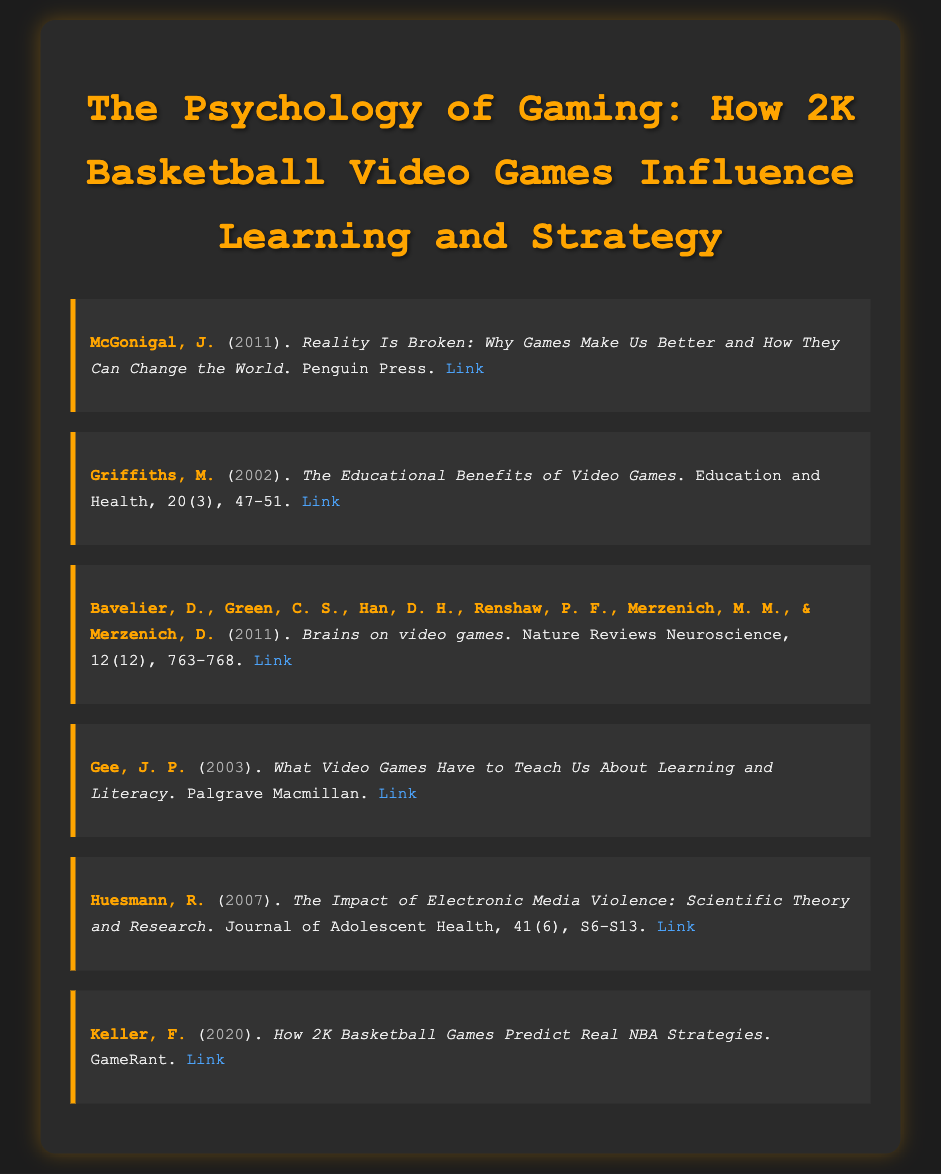What is the title of the document? The title appears at the top of the document and summarizes the main theme.
Answer: The Psychology of Gaming: How 2K Basketball Video Games Influence Learning and Strategy Who is the author of the book "Reality Is Broken"? The author’s name is listed at the beginning of the first item in the bibliography.
Answer: McGonigal, J What year was "The Educational Benefits of Video Games" published? The year is shown in parentheses after the author's name in the second item.
Answer: 2002 Which journal published "The Impact of Electronic Media Violence"? The journal name is found in the citation within the bibliography item.
Answer: Journal of Adolescent Health How many authors contributed to the article "Brains on video games"? The number of authors is counted based on the list in the citation of the third item.
Answer: Six Which game predicts real NBA strategies according to Keller's article? The specific game mentioned in the citation of the sixth item provides this information.
Answer: 2K Basketball Games What is a common theme in the bibliography? The common topic relates to the influence of video games on learning strategies.
Answer: Influence of video games What type of document is this? The nature of the document is indicated by the context and formatting, specific to citations.
Answer: Bibliography 